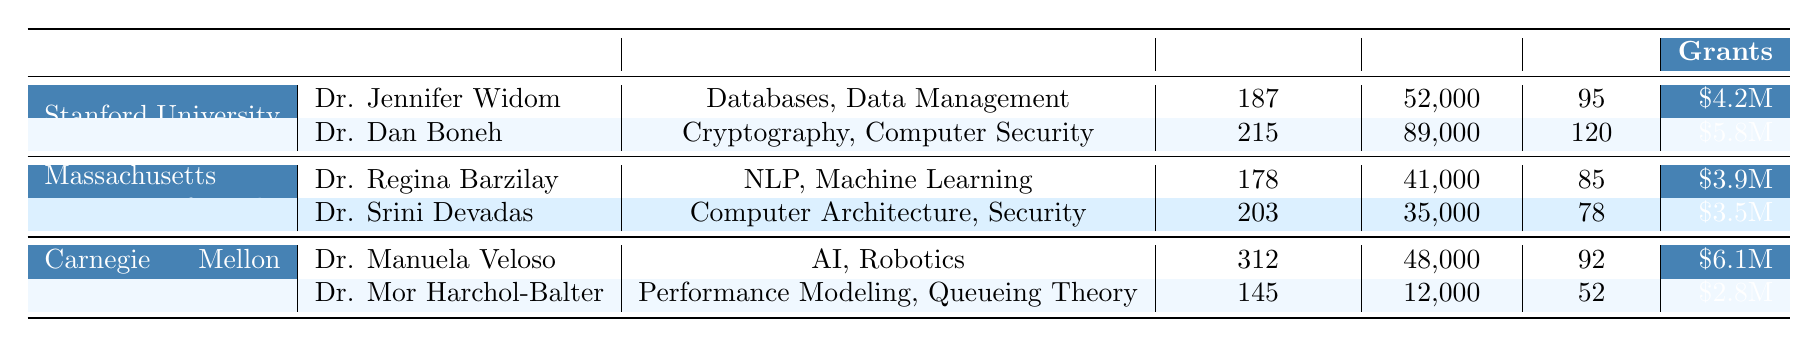What is the total number of publications by all faculty members combined? The total publications can be calculated by adding the publications of each faculty member: 187 (Jennifer Widom) + 215 (Dan Boneh) + 178 (Regina Barzilay) + 203 (Srini Devadas) + 312 (Manuela Veloso) + 145 (Mor Harchol-Balter) = 1240.
Answer: 1240 Which professor has the highest h-index among the listed faculty? The h-index values for each professor are: 95 (Jennifer Widom), 120 (Dan Boneh), 85 (Regina Barzilay), 78 (Srini Devadas), 92 (Manuela Veloso), and 52 (Mor Harchol-Balter). Dan Boneh has the highest h-index of 120.
Answer: Dan Boneh Is the total grants funding more at Stanford University than at MIT? The total grants funding for Stanford is $4.2M + $5.8M = $10M. For MIT, it is $3.9M + $3.5M = $7.4M. Since $10M > $7.4M, Stanford has more funding.
Answer: Yes What is the average number of publications for faculty at Carnegie Mellon University? The total publications for Carnegie Mellon faculty is 312 + 145 = 457. There are two faculty members, so the average is 457/2 = 228.5.
Answer: 228.5 Which research area is represented by the most publications? Summing up publications by research areas: Databases and Data Management (187 + 215 = 402), NLP and Machine Learning (178 + 203 = 381), AI and Robotics (312), and Performance Modeling (145). AI and Robotics has the most publications with 312.
Answer: AI and Robotics Do professors from MIT collectively have more citations than those from Stanford? Total citations for MIT professors: 41000 (Regina Barzilay) + 35000 (Srini Devadas) = 76000. Total for Stanford professors: 52000 (Jennifer Widom) + 89000 (Dan Boneh) = 141000. Since 76000 < 141000, MIT has fewer citations.
Answer: No How much more grant funding does Carnegie Mellon University have compared to MIT? Total grants for Carnegie Mellon: $6.1M + $2.8M = $8.9M. Total for MIT: $3.9M + $3.5M = $7.4M. The difference is $8.9M - $7.4M = $1.5M.
Answer: $1.5M Which university has the most faculty publications in total? Total publications for each university: Stanford (402), MIT (381), and Carnegie Mellon (457). Carnegie Mellon University has the highest total publications.
Answer: Carnegie Mellon University 